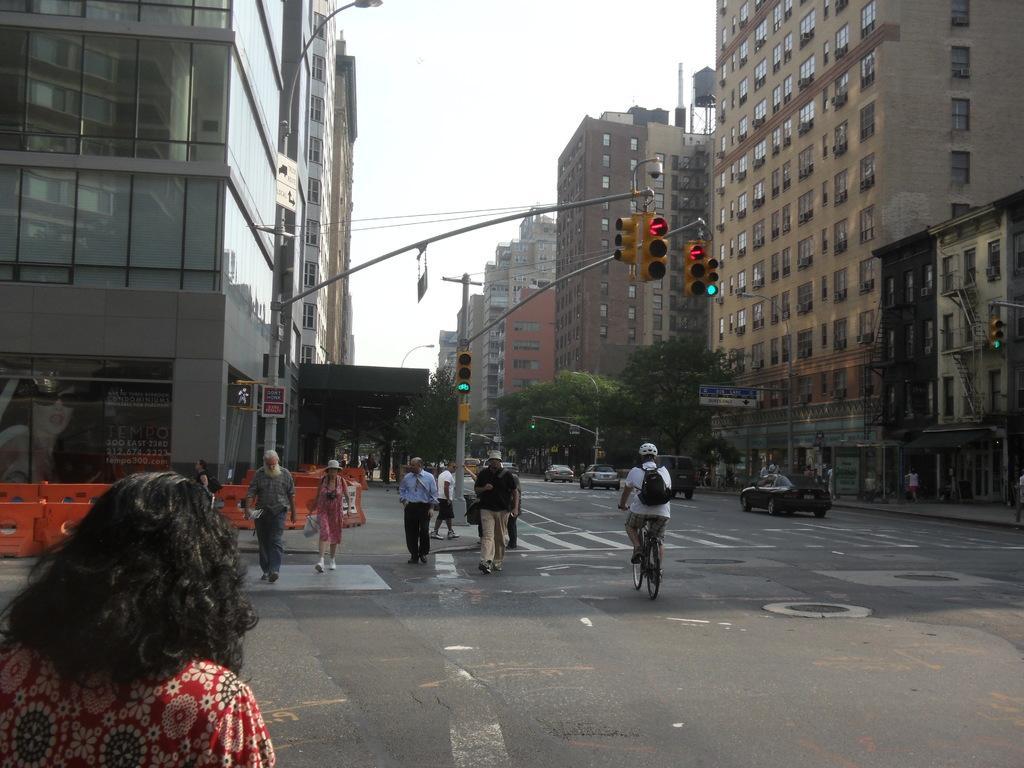Can you describe this image briefly? In this picture we can see persons,vehicles on the road and in the background we can see buildings,trees,traffic signals,sky. 